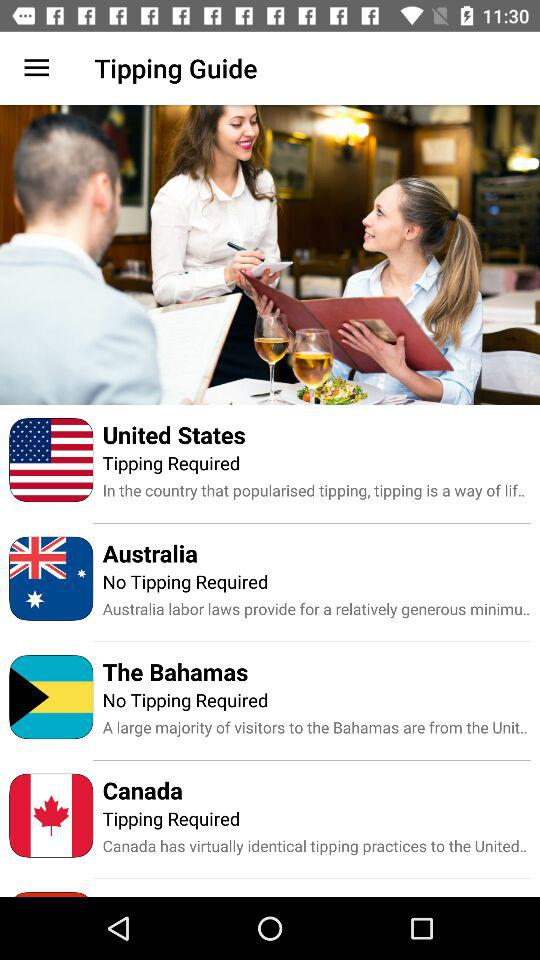How many countries have a tipping requirement?
Answer the question using a single word or phrase. 2 